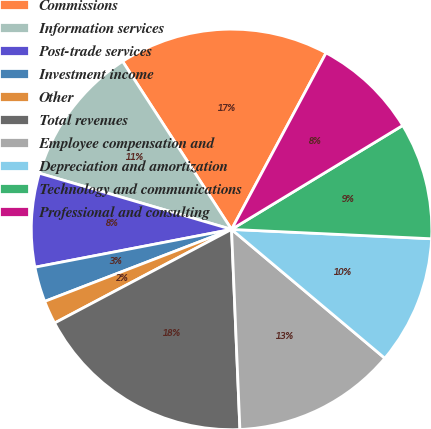<chart> <loc_0><loc_0><loc_500><loc_500><pie_chart><fcel>Commissions<fcel>Information services<fcel>Post-trade services<fcel>Investment income<fcel>Other<fcel>Total revenues<fcel>Employee compensation and<fcel>Depreciation and amortization<fcel>Technology and communications<fcel>Professional and consulting<nl><fcel>16.98%<fcel>11.32%<fcel>7.55%<fcel>2.83%<fcel>1.89%<fcel>17.92%<fcel>13.21%<fcel>10.38%<fcel>9.43%<fcel>8.49%<nl></chart> 